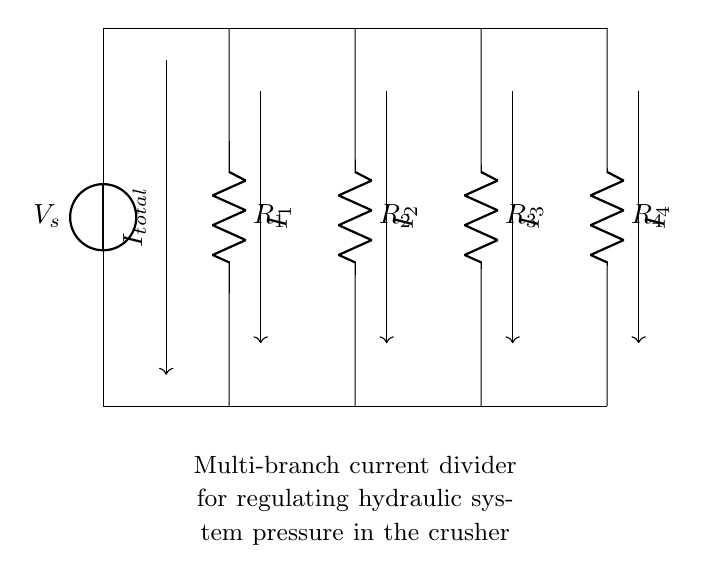What is the source voltage in this circuit? The source voltage is labeled as V_s at the top left of the diagram, indicating the voltage supplied to the circuit.
Answer: V_s How many resistors are present in the circuit? There are four resistors labeled as R1, R2, R3, and R4 in the circuit, which are connected in parallel as part of the current divider.
Answer: 4 What is the total current entering the circuit? The total current entering the circuit is represented by I_total, shown as entering the top of the circuit at the source.
Answer: I_total What type of current divider is represented in this circuit? This circuit is a multi-branch current divider, as it divides the input current into multiple branches through several parallel paths formed by the resistors.
Answer: Multi-branch Which resistor has the highest resistance? To determine which resistor has the highest resistance, further values or specifications would be needed. Since no resistance values are provided, it can't be definitively answered from the diagram.
Answer: Cannot determine How is the current divided among the resistors? The current is divided among the resistors based on the resistance values according to Ohm's Law (I = V/R). Each resistor receives a portion of the total current inversely proportional to its resistance.
Answer: Based on resistance values What do the arrows in the circuit represent? The arrows represent the direction of current flow, indicating how the current divides among the different branches connected to the resistors.
Answer: Direction of current flow 